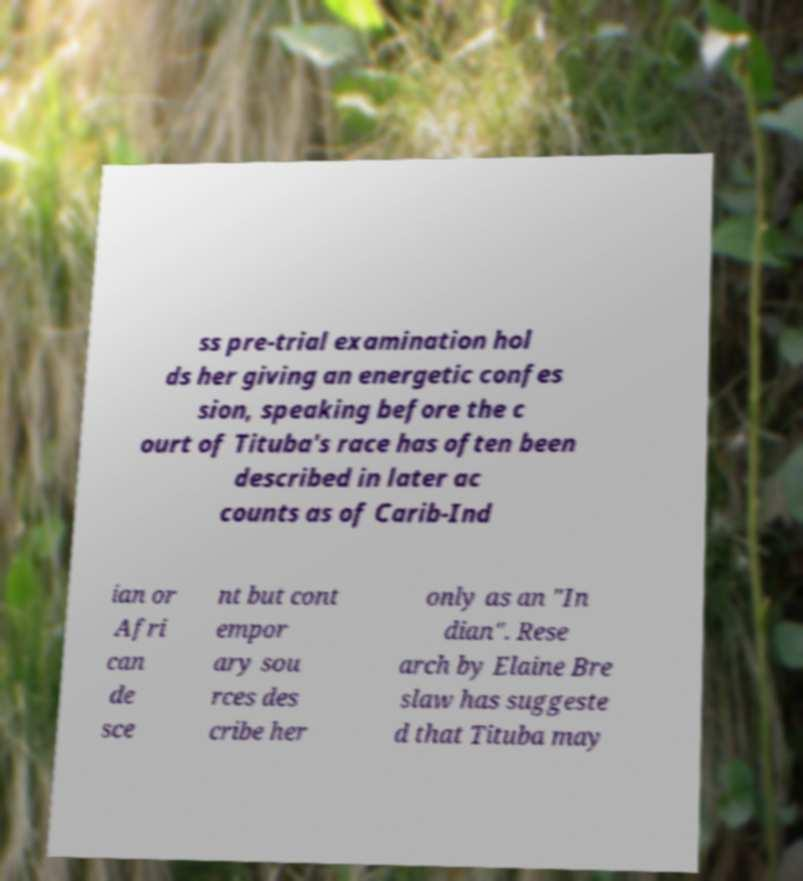Could you assist in decoding the text presented in this image and type it out clearly? ss pre-trial examination hol ds her giving an energetic confes sion, speaking before the c ourt of Tituba's race has often been described in later ac counts as of Carib-Ind ian or Afri can de sce nt but cont empor ary sou rces des cribe her only as an "In dian". Rese arch by Elaine Bre slaw has suggeste d that Tituba may 